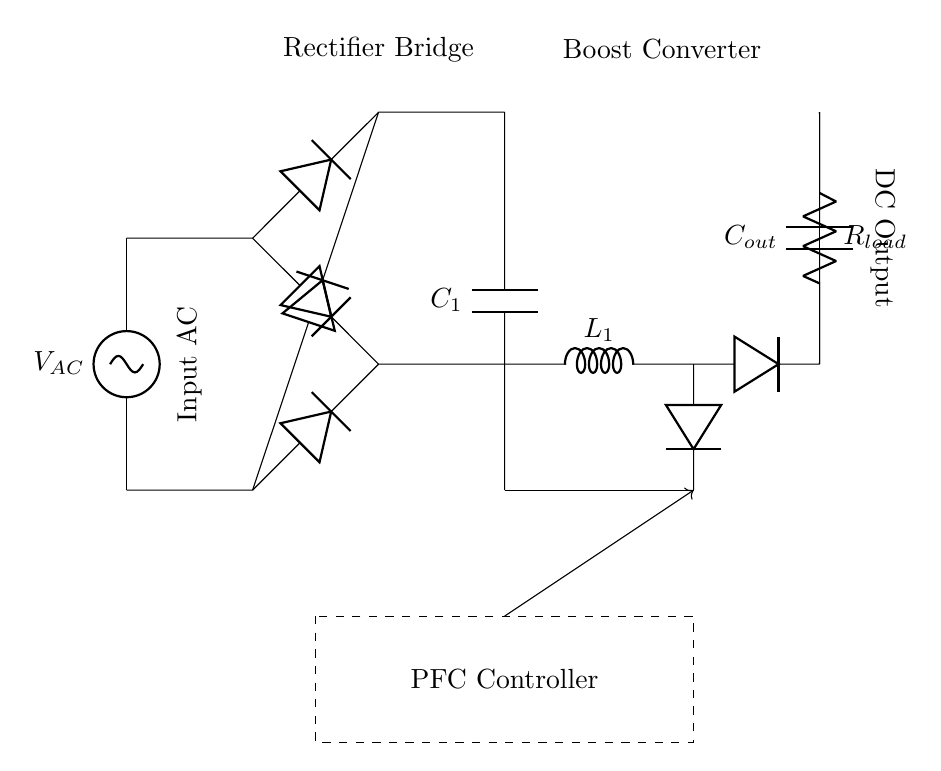What is the input voltage type of this circuit? The input voltage type is AC, as indicated by the label next to the voltage source in the diagram.
Answer: AC What does the R in the circuit represent? The R in the circuit represents a resistive load, which is indicated in the diagram as R_load. It absorbs power in the circuit.
Answer: Resistive load What function does the PFC controller serve? The PFC controller is responsible for managing power factor correction in the circuit, ensuring that the load operates efficiently by optimizing the relationship between voltage and current.
Answer: Power factor correction What components are included in the rectifier bridge? The rectifier bridge consists of four diodes, which convert the AC input voltage to DC, shown in the diagram connecting in a bridge configuration.
Answer: Four diodes What is the purpose of the output capacitor in this circuit? The output capacitor serves to smooth the DC output voltage by filtering out fluctuations, thereby providing a steadier voltage to the load.
Answer: Smoothing DC output How many phases are used in this power factor correction circuit? The circuit diagram indicates a single-phase system as evidenced by the single AC voltage source and its configuration.
Answer: Single-phase What is the role of the boost converter in this circuit? The boost converter increases the DC voltage obtained from the rectifier bridge to a higher level needed by the load, thus converting the voltage for better efficiency.
Answer: Increase DC voltage 